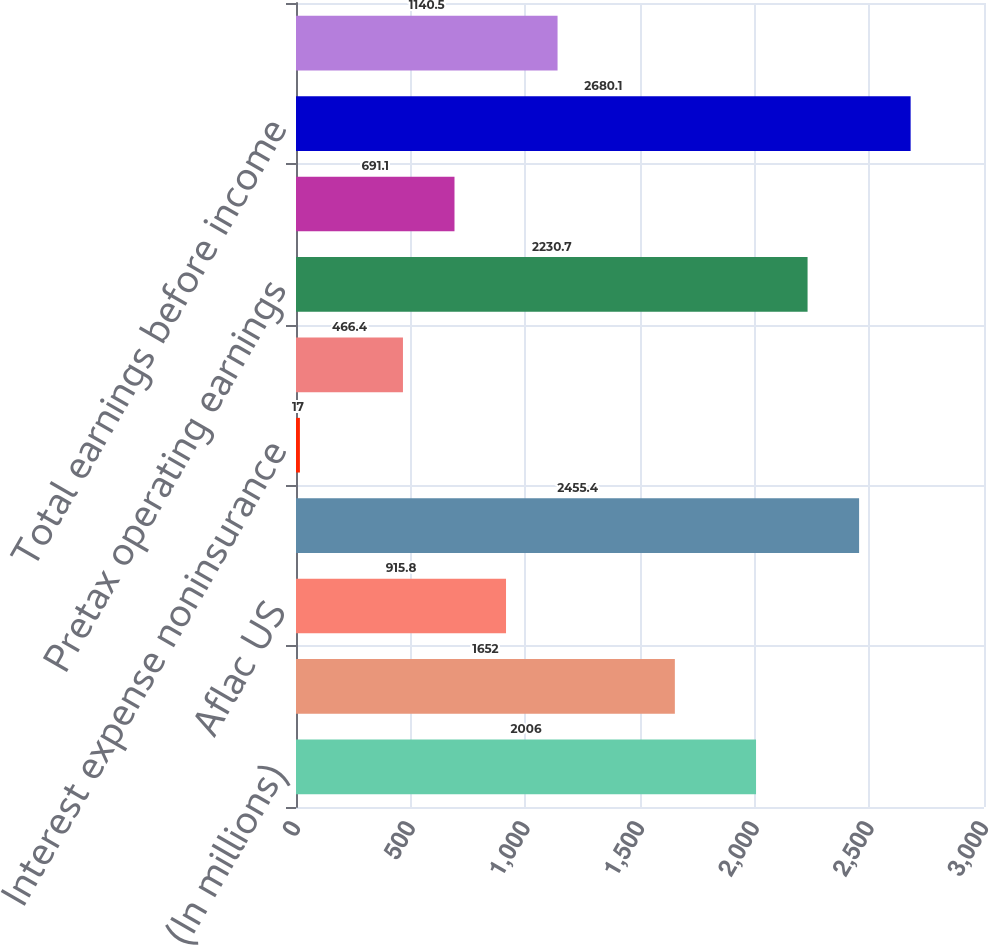Convert chart to OTSL. <chart><loc_0><loc_0><loc_500><loc_500><bar_chart><fcel>(In millions)<fcel>Aflac Japan<fcel>Aflac US<fcel>Total business segments<fcel>Interest expense noninsurance<fcel>Corporate and eliminations<fcel>Pretax operating earnings<fcel>Realized investment gains<fcel>Total earnings before income<fcel>Income taxes applicable to<nl><fcel>2006<fcel>1652<fcel>915.8<fcel>2455.4<fcel>17<fcel>466.4<fcel>2230.7<fcel>691.1<fcel>2680.1<fcel>1140.5<nl></chart> 